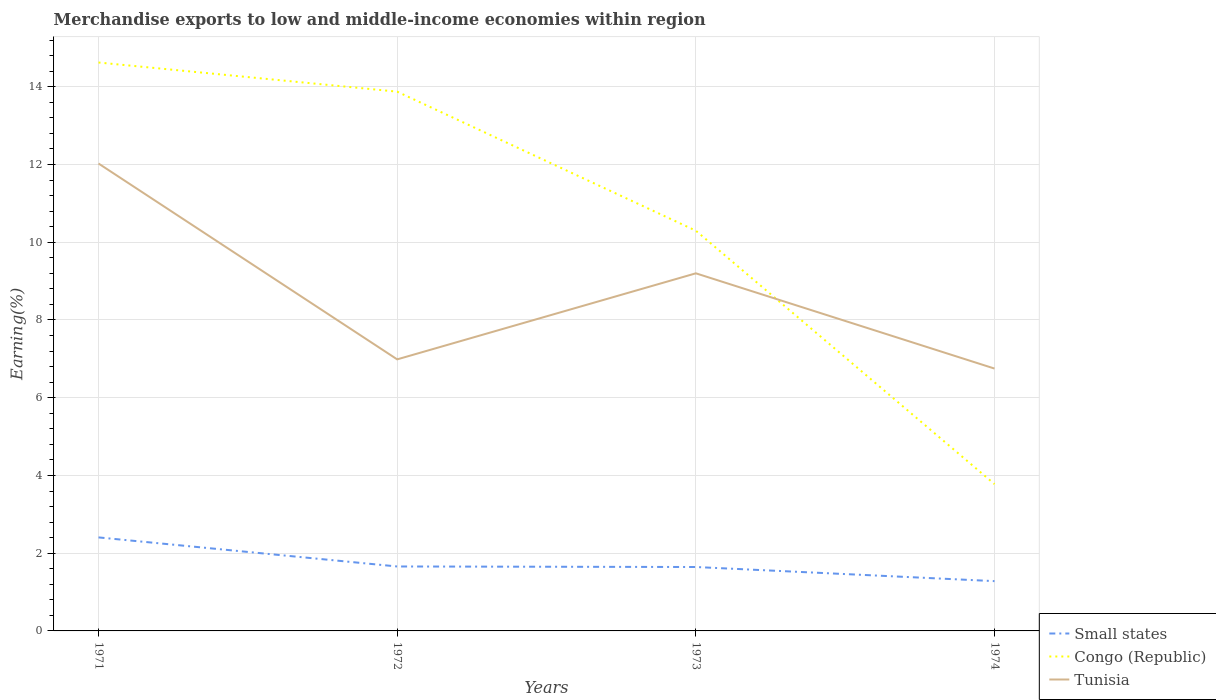How many different coloured lines are there?
Your answer should be very brief. 3. Is the number of lines equal to the number of legend labels?
Give a very brief answer. Yes. Across all years, what is the maximum percentage of amount earned from merchandise exports in Small states?
Keep it short and to the point. 1.28. In which year was the percentage of amount earned from merchandise exports in Congo (Republic) maximum?
Your response must be concise. 1974. What is the total percentage of amount earned from merchandise exports in Tunisia in the graph?
Your answer should be compact. 2.45. What is the difference between the highest and the second highest percentage of amount earned from merchandise exports in Tunisia?
Your answer should be very brief. 5.28. What is the difference between the highest and the lowest percentage of amount earned from merchandise exports in Congo (Republic)?
Offer a very short reply. 2. How many years are there in the graph?
Your answer should be compact. 4. What is the difference between two consecutive major ticks on the Y-axis?
Make the answer very short. 2. Does the graph contain any zero values?
Make the answer very short. No. Does the graph contain grids?
Provide a succinct answer. Yes. Where does the legend appear in the graph?
Your response must be concise. Bottom right. How many legend labels are there?
Keep it short and to the point. 3. How are the legend labels stacked?
Provide a succinct answer. Vertical. What is the title of the graph?
Keep it short and to the point. Merchandise exports to low and middle-income economies within region. Does "Kiribati" appear as one of the legend labels in the graph?
Provide a short and direct response. No. What is the label or title of the X-axis?
Your answer should be very brief. Years. What is the label or title of the Y-axis?
Provide a short and direct response. Earning(%). What is the Earning(%) of Small states in 1971?
Your answer should be very brief. 2.41. What is the Earning(%) in Congo (Republic) in 1971?
Make the answer very short. 14.63. What is the Earning(%) in Tunisia in 1971?
Your answer should be very brief. 12.03. What is the Earning(%) of Small states in 1972?
Provide a succinct answer. 1.66. What is the Earning(%) of Congo (Republic) in 1972?
Make the answer very short. 13.88. What is the Earning(%) of Tunisia in 1972?
Your answer should be compact. 6.99. What is the Earning(%) in Small states in 1973?
Make the answer very short. 1.64. What is the Earning(%) in Congo (Republic) in 1973?
Your response must be concise. 10.3. What is the Earning(%) in Tunisia in 1973?
Your answer should be very brief. 9.2. What is the Earning(%) in Small states in 1974?
Provide a succinct answer. 1.28. What is the Earning(%) in Congo (Republic) in 1974?
Make the answer very short. 3.78. What is the Earning(%) in Tunisia in 1974?
Provide a succinct answer. 6.75. Across all years, what is the maximum Earning(%) of Small states?
Provide a succinct answer. 2.41. Across all years, what is the maximum Earning(%) in Congo (Republic)?
Make the answer very short. 14.63. Across all years, what is the maximum Earning(%) in Tunisia?
Ensure brevity in your answer.  12.03. Across all years, what is the minimum Earning(%) of Small states?
Offer a very short reply. 1.28. Across all years, what is the minimum Earning(%) in Congo (Republic)?
Your answer should be very brief. 3.78. Across all years, what is the minimum Earning(%) in Tunisia?
Give a very brief answer. 6.75. What is the total Earning(%) in Small states in the graph?
Your response must be concise. 6.99. What is the total Earning(%) in Congo (Republic) in the graph?
Provide a short and direct response. 42.58. What is the total Earning(%) in Tunisia in the graph?
Provide a succinct answer. 34.96. What is the difference between the Earning(%) in Small states in 1971 and that in 1972?
Offer a very short reply. 0.75. What is the difference between the Earning(%) in Congo (Republic) in 1971 and that in 1972?
Give a very brief answer. 0.75. What is the difference between the Earning(%) in Tunisia in 1971 and that in 1972?
Your response must be concise. 5.04. What is the difference between the Earning(%) of Small states in 1971 and that in 1973?
Ensure brevity in your answer.  0.76. What is the difference between the Earning(%) in Congo (Republic) in 1971 and that in 1973?
Make the answer very short. 4.33. What is the difference between the Earning(%) in Tunisia in 1971 and that in 1973?
Make the answer very short. 2.83. What is the difference between the Earning(%) in Small states in 1971 and that in 1974?
Your answer should be very brief. 1.13. What is the difference between the Earning(%) in Congo (Republic) in 1971 and that in 1974?
Offer a very short reply. 10.85. What is the difference between the Earning(%) of Tunisia in 1971 and that in 1974?
Your answer should be very brief. 5.28. What is the difference between the Earning(%) in Small states in 1972 and that in 1973?
Keep it short and to the point. 0.01. What is the difference between the Earning(%) of Congo (Republic) in 1972 and that in 1973?
Offer a terse response. 3.58. What is the difference between the Earning(%) in Tunisia in 1972 and that in 1973?
Offer a very short reply. -2.21. What is the difference between the Earning(%) of Small states in 1972 and that in 1974?
Provide a short and direct response. 0.38. What is the difference between the Earning(%) of Congo (Republic) in 1972 and that in 1974?
Your response must be concise. 10.1. What is the difference between the Earning(%) in Tunisia in 1972 and that in 1974?
Your response must be concise. 0.24. What is the difference between the Earning(%) of Small states in 1973 and that in 1974?
Make the answer very short. 0.36. What is the difference between the Earning(%) of Congo (Republic) in 1973 and that in 1974?
Make the answer very short. 6.52. What is the difference between the Earning(%) in Tunisia in 1973 and that in 1974?
Your response must be concise. 2.45. What is the difference between the Earning(%) of Small states in 1971 and the Earning(%) of Congo (Republic) in 1972?
Your answer should be very brief. -11.47. What is the difference between the Earning(%) of Small states in 1971 and the Earning(%) of Tunisia in 1972?
Keep it short and to the point. -4.58. What is the difference between the Earning(%) in Congo (Republic) in 1971 and the Earning(%) in Tunisia in 1972?
Offer a very short reply. 7.64. What is the difference between the Earning(%) of Small states in 1971 and the Earning(%) of Congo (Republic) in 1973?
Your answer should be very brief. -7.89. What is the difference between the Earning(%) in Small states in 1971 and the Earning(%) in Tunisia in 1973?
Make the answer very short. -6.79. What is the difference between the Earning(%) of Congo (Republic) in 1971 and the Earning(%) of Tunisia in 1973?
Make the answer very short. 5.42. What is the difference between the Earning(%) of Small states in 1971 and the Earning(%) of Congo (Republic) in 1974?
Provide a succinct answer. -1.37. What is the difference between the Earning(%) in Small states in 1971 and the Earning(%) in Tunisia in 1974?
Your answer should be compact. -4.34. What is the difference between the Earning(%) of Congo (Republic) in 1971 and the Earning(%) of Tunisia in 1974?
Provide a short and direct response. 7.87. What is the difference between the Earning(%) of Small states in 1972 and the Earning(%) of Congo (Republic) in 1973?
Your answer should be very brief. -8.64. What is the difference between the Earning(%) in Small states in 1972 and the Earning(%) in Tunisia in 1973?
Your answer should be very brief. -7.54. What is the difference between the Earning(%) of Congo (Republic) in 1972 and the Earning(%) of Tunisia in 1973?
Your response must be concise. 4.67. What is the difference between the Earning(%) of Small states in 1972 and the Earning(%) of Congo (Republic) in 1974?
Provide a succinct answer. -2.12. What is the difference between the Earning(%) in Small states in 1972 and the Earning(%) in Tunisia in 1974?
Your answer should be compact. -5.09. What is the difference between the Earning(%) of Congo (Republic) in 1972 and the Earning(%) of Tunisia in 1974?
Make the answer very short. 7.12. What is the difference between the Earning(%) in Small states in 1973 and the Earning(%) in Congo (Republic) in 1974?
Ensure brevity in your answer.  -2.13. What is the difference between the Earning(%) in Small states in 1973 and the Earning(%) in Tunisia in 1974?
Your response must be concise. -5.11. What is the difference between the Earning(%) in Congo (Republic) in 1973 and the Earning(%) in Tunisia in 1974?
Provide a succinct answer. 3.55. What is the average Earning(%) in Small states per year?
Keep it short and to the point. 1.75. What is the average Earning(%) of Congo (Republic) per year?
Offer a terse response. 10.64. What is the average Earning(%) in Tunisia per year?
Give a very brief answer. 8.74. In the year 1971, what is the difference between the Earning(%) in Small states and Earning(%) in Congo (Republic)?
Ensure brevity in your answer.  -12.22. In the year 1971, what is the difference between the Earning(%) in Small states and Earning(%) in Tunisia?
Ensure brevity in your answer.  -9.62. In the year 1971, what is the difference between the Earning(%) of Congo (Republic) and Earning(%) of Tunisia?
Make the answer very short. 2.6. In the year 1972, what is the difference between the Earning(%) in Small states and Earning(%) in Congo (Republic)?
Ensure brevity in your answer.  -12.22. In the year 1972, what is the difference between the Earning(%) of Small states and Earning(%) of Tunisia?
Ensure brevity in your answer.  -5.33. In the year 1972, what is the difference between the Earning(%) in Congo (Republic) and Earning(%) in Tunisia?
Your response must be concise. 6.89. In the year 1973, what is the difference between the Earning(%) in Small states and Earning(%) in Congo (Republic)?
Ensure brevity in your answer.  -8.65. In the year 1973, what is the difference between the Earning(%) in Small states and Earning(%) in Tunisia?
Keep it short and to the point. -7.56. In the year 1973, what is the difference between the Earning(%) in Congo (Republic) and Earning(%) in Tunisia?
Your answer should be very brief. 1.1. In the year 1974, what is the difference between the Earning(%) of Small states and Earning(%) of Congo (Republic)?
Ensure brevity in your answer.  -2.5. In the year 1974, what is the difference between the Earning(%) in Small states and Earning(%) in Tunisia?
Offer a terse response. -5.47. In the year 1974, what is the difference between the Earning(%) in Congo (Republic) and Earning(%) in Tunisia?
Give a very brief answer. -2.97. What is the ratio of the Earning(%) in Small states in 1971 to that in 1972?
Your answer should be compact. 1.45. What is the ratio of the Earning(%) of Congo (Republic) in 1971 to that in 1972?
Offer a terse response. 1.05. What is the ratio of the Earning(%) in Tunisia in 1971 to that in 1972?
Give a very brief answer. 1.72. What is the ratio of the Earning(%) in Small states in 1971 to that in 1973?
Provide a short and direct response. 1.46. What is the ratio of the Earning(%) in Congo (Republic) in 1971 to that in 1973?
Give a very brief answer. 1.42. What is the ratio of the Earning(%) of Tunisia in 1971 to that in 1973?
Offer a terse response. 1.31. What is the ratio of the Earning(%) in Small states in 1971 to that in 1974?
Your response must be concise. 1.88. What is the ratio of the Earning(%) of Congo (Republic) in 1971 to that in 1974?
Give a very brief answer. 3.87. What is the ratio of the Earning(%) of Tunisia in 1971 to that in 1974?
Ensure brevity in your answer.  1.78. What is the ratio of the Earning(%) of Small states in 1972 to that in 1973?
Provide a short and direct response. 1.01. What is the ratio of the Earning(%) in Congo (Republic) in 1972 to that in 1973?
Your answer should be compact. 1.35. What is the ratio of the Earning(%) of Tunisia in 1972 to that in 1973?
Provide a short and direct response. 0.76. What is the ratio of the Earning(%) of Small states in 1972 to that in 1974?
Offer a terse response. 1.29. What is the ratio of the Earning(%) of Congo (Republic) in 1972 to that in 1974?
Offer a terse response. 3.67. What is the ratio of the Earning(%) of Tunisia in 1972 to that in 1974?
Your answer should be very brief. 1.03. What is the ratio of the Earning(%) of Small states in 1973 to that in 1974?
Provide a short and direct response. 1.28. What is the ratio of the Earning(%) of Congo (Republic) in 1973 to that in 1974?
Offer a terse response. 2.73. What is the ratio of the Earning(%) of Tunisia in 1973 to that in 1974?
Keep it short and to the point. 1.36. What is the difference between the highest and the second highest Earning(%) in Small states?
Ensure brevity in your answer.  0.75. What is the difference between the highest and the second highest Earning(%) of Congo (Republic)?
Offer a terse response. 0.75. What is the difference between the highest and the second highest Earning(%) in Tunisia?
Your response must be concise. 2.83. What is the difference between the highest and the lowest Earning(%) in Small states?
Your answer should be very brief. 1.13. What is the difference between the highest and the lowest Earning(%) of Congo (Republic)?
Provide a short and direct response. 10.85. What is the difference between the highest and the lowest Earning(%) of Tunisia?
Provide a succinct answer. 5.28. 